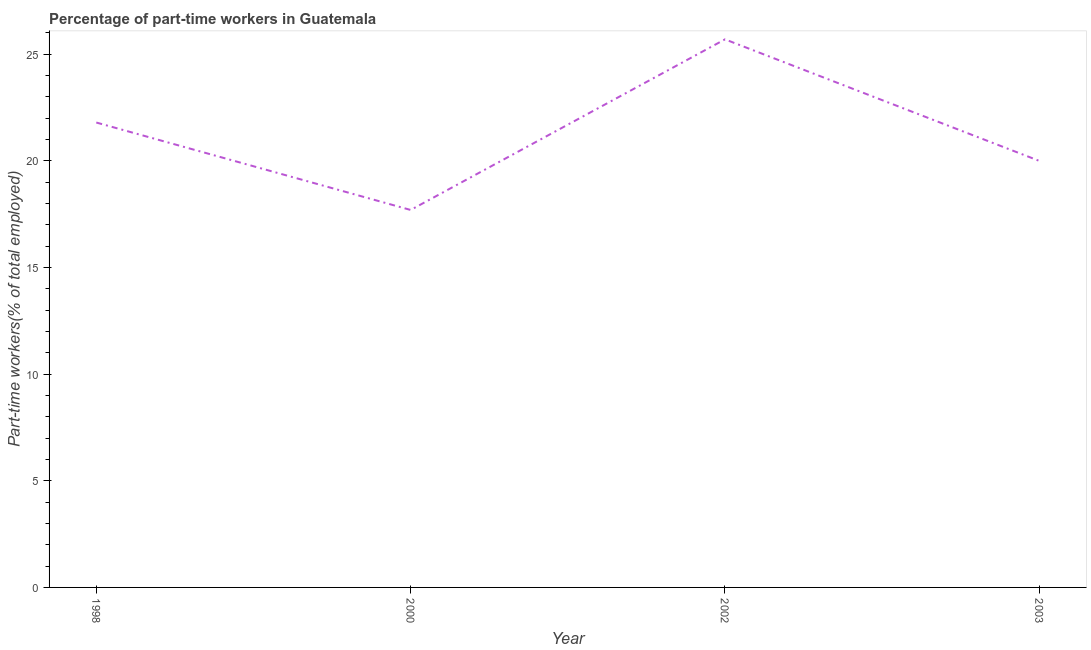What is the percentage of part-time workers in 2003?
Provide a succinct answer. 20. Across all years, what is the maximum percentage of part-time workers?
Offer a terse response. 25.7. Across all years, what is the minimum percentage of part-time workers?
Provide a short and direct response. 17.7. In which year was the percentage of part-time workers minimum?
Your answer should be very brief. 2000. What is the sum of the percentage of part-time workers?
Provide a short and direct response. 85.2. What is the difference between the percentage of part-time workers in 1998 and 2000?
Your answer should be very brief. 4.1. What is the average percentage of part-time workers per year?
Provide a short and direct response. 21.3. What is the median percentage of part-time workers?
Your response must be concise. 20.9. In how many years, is the percentage of part-time workers greater than 17 %?
Your answer should be very brief. 4. Do a majority of the years between 1998 and 2003 (inclusive) have percentage of part-time workers greater than 24 %?
Provide a short and direct response. No. What is the ratio of the percentage of part-time workers in 2000 to that in 2003?
Provide a succinct answer. 0.89. Is the difference between the percentage of part-time workers in 2000 and 2002 greater than the difference between any two years?
Your response must be concise. Yes. What is the difference between the highest and the second highest percentage of part-time workers?
Your answer should be compact. 3.9. Is the sum of the percentage of part-time workers in 2002 and 2003 greater than the maximum percentage of part-time workers across all years?
Offer a very short reply. Yes. What is the difference between the highest and the lowest percentage of part-time workers?
Make the answer very short. 8. What is the difference between two consecutive major ticks on the Y-axis?
Your answer should be very brief. 5. Are the values on the major ticks of Y-axis written in scientific E-notation?
Give a very brief answer. No. Does the graph contain grids?
Provide a short and direct response. No. What is the title of the graph?
Your answer should be compact. Percentage of part-time workers in Guatemala. What is the label or title of the X-axis?
Make the answer very short. Year. What is the label or title of the Y-axis?
Offer a very short reply. Part-time workers(% of total employed). What is the Part-time workers(% of total employed) of 1998?
Make the answer very short. 21.8. What is the Part-time workers(% of total employed) in 2000?
Keep it short and to the point. 17.7. What is the Part-time workers(% of total employed) of 2002?
Give a very brief answer. 25.7. What is the difference between the Part-time workers(% of total employed) in 1998 and 2002?
Provide a short and direct response. -3.9. What is the difference between the Part-time workers(% of total employed) in 1998 and 2003?
Provide a short and direct response. 1.8. What is the difference between the Part-time workers(% of total employed) in 2000 and 2003?
Keep it short and to the point. -2.3. What is the difference between the Part-time workers(% of total employed) in 2002 and 2003?
Give a very brief answer. 5.7. What is the ratio of the Part-time workers(% of total employed) in 1998 to that in 2000?
Offer a very short reply. 1.23. What is the ratio of the Part-time workers(% of total employed) in 1998 to that in 2002?
Keep it short and to the point. 0.85. What is the ratio of the Part-time workers(% of total employed) in 1998 to that in 2003?
Provide a succinct answer. 1.09. What is the ratio of the Part-time workers(% of total employed) in 2000 to that in 2002?
Provide a succinct answer. 0.69. What is the ratio of the Part-time workers(% of total employed) in 2000 to that in 2003?
Provide a short and direct response. 0.89. What is the ratio of the Part-time workers(% of total employed) in 2002 to that in 2003?
Provide a short and direct response. 1.28. 